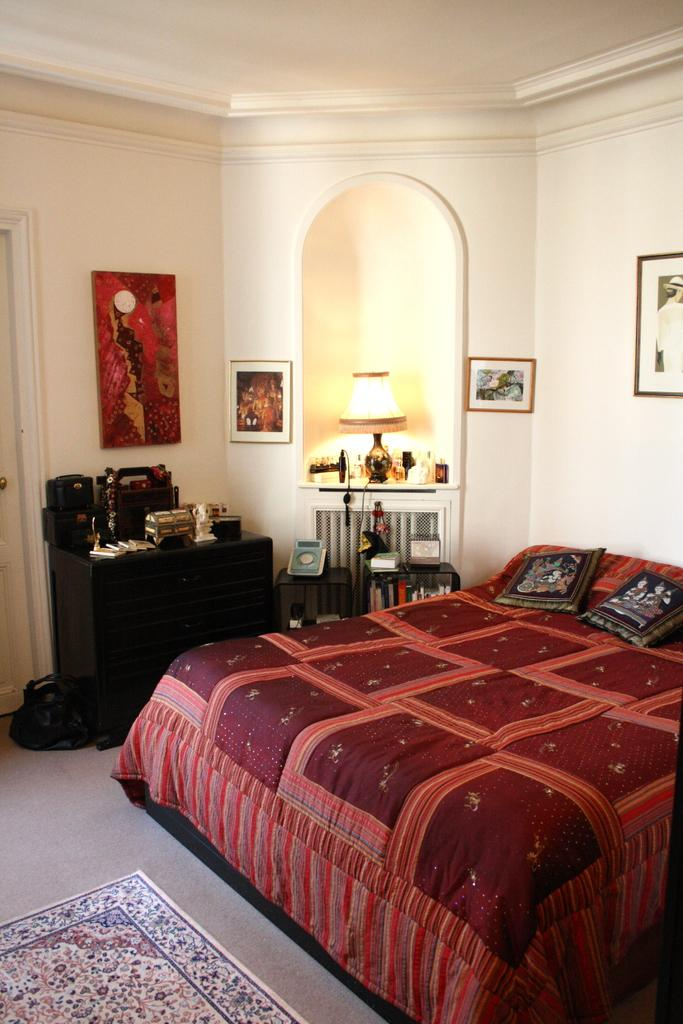What type of furniture is located on the right side of the image? There is a bed on the right side of the image. What other piece of furniture can be seen in the image? There is a wooden drawer in the image. What type of lighting is present in the image? There is a table lamp in the image. What is attached to the wall in the image? There are photo frames fixed to a wall in the image. What type of mitten is hanging on the wall in the image? There is no mitten present in the image; only a bed, wooden drawer, table lamp, and photo frames are visible. 